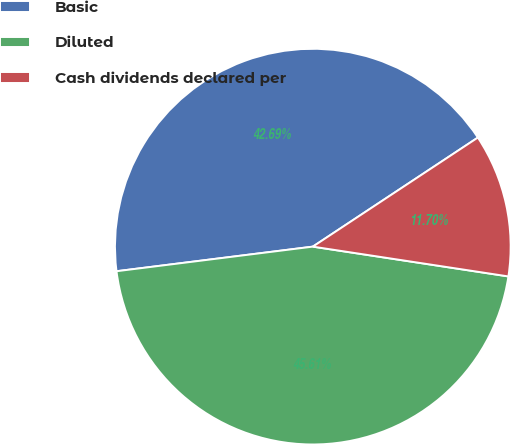Convert chart. <chart><loc_0><loc_0><loc_500><loc_500><pie_chart><fcel>Basic<fcel>Diluted<fcel>Cash dividends declared per<nl><fcel>42.69%<fcel>45.61%<fcel>11.7%<nl></chart> 